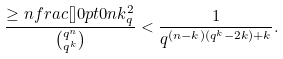<formula> <loc_0><loc_0><loc_500><loc_500>\frac { \geq n f r a c { [ } { ] } { 0 p t } { 0 } n k _ { q } ^ { 2 } } { \binom { q ^ { n } } { q ^ { k } } } < \frac { 1 } { q ^ { ( n - k ) ( q ^ { k } - 2 k ) + k } } .</formula> 